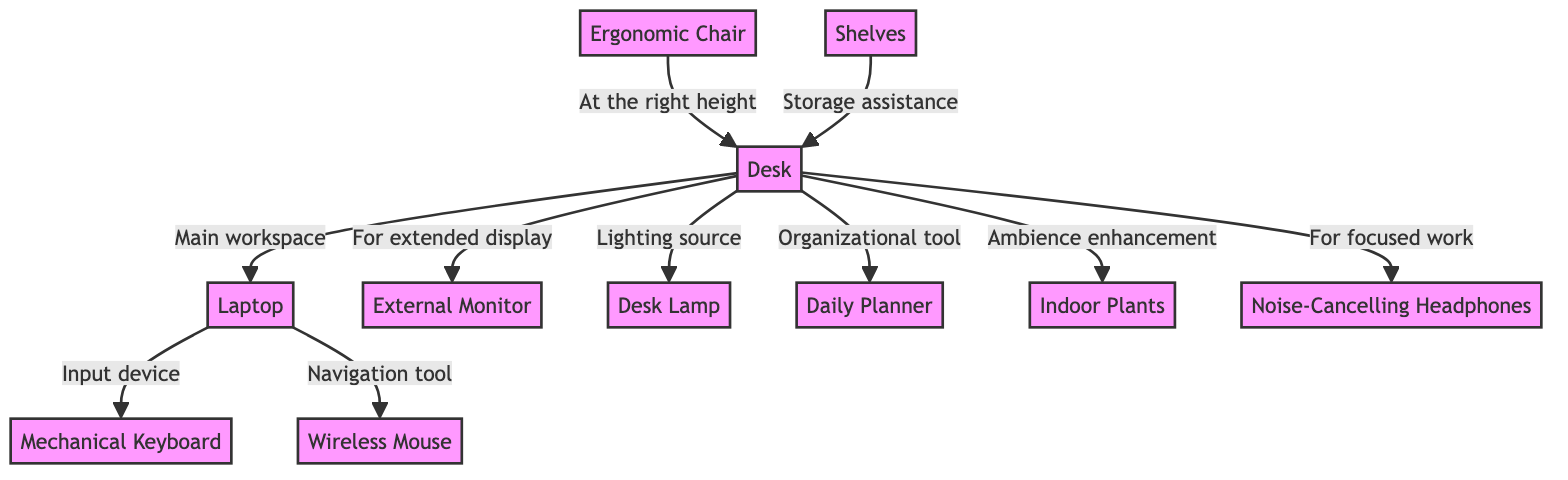What is the main workspace in the diagram? The main workspace is indicated by the connection from the desk to the laptop, showing that the laptop is situated on the desk, which serves as the primary work area.
Answer: Laptop How many nodes are there in the diagram? By counting all the distinct items represented in the diagram, we find a total of ten nodes: desk, chair, laptop, monitor, keyboard, mouse, lamp, planner, plants, and headphones.
Answer: Ten What relationship exists between the chair and the desk? The relationship between the chair and the desk is described as "At the right height," indicating that the chair is positioned such that it properly aligns with the desk for ergonomics.
Answer: At the right height Which item serves as a lighting source? The diagram indicates that the lamp is connected to the desk and is labeled as the lighting source, showing its purpose in the workspace setup.
Answer: Lamp What do the indoor plants contribute to the workspace? The indoor plants are described as enhancing ambience, indicating that they add to the motivational and aesthetic quality of the workspace.
Answer: Ambience enhancement How does the monitor connect to the desk? The monitor connects to the desk with the label "For extended display," which indicates its purpose as a supplemental screen when working on the desk.
Answer: For extended display What is the relationship between the planner and the desk? The planner is noted as an organizational tool linked to the desk, suggesting that it helps in planning tasks and keeping the workspace organized.
Answer: Organizational tool Which equipment is used for navigation in the workspace? The mouse is specifically labeled as the navigation tool connected to the laptop, indicating its function in aiding navigation when using the laptop.
Answer: Navigation tool How do shelves relate to the desk? The shelves are labeled as "Storage assistance," which indicates their role in providing additional storage options for organizing items on or around the desk.
Answer: Storage assistance 